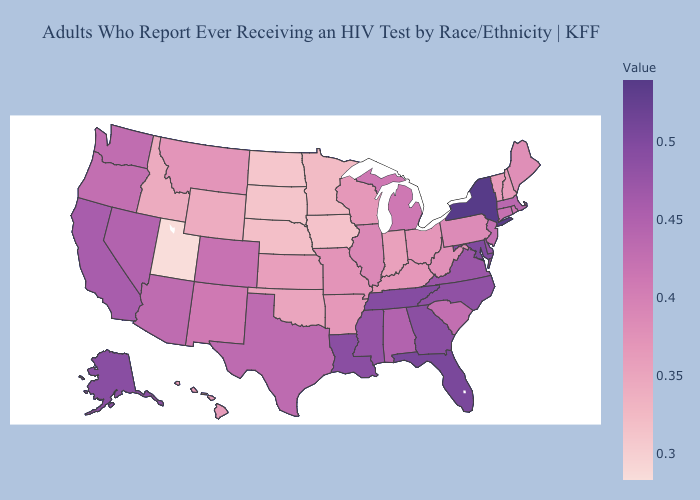Does Missouri have a higher value than New Mexico?
Keep it brief. No. Among the states that border Montana , which have the highest value?
Concise answer only. Idaho. Does New Hampshire have the lowest value in the Northeast?
Short answer required. Yes. Which states hav the highest value in the South?
Answer briefly. Florida. Which states have the lowest value in the USA?
Answer briefly. Utah. Which states hav the highest value in the West?
Answer briefly. Alaska. Does Texas have the highest value in the USA?
Quick response, please. No. 